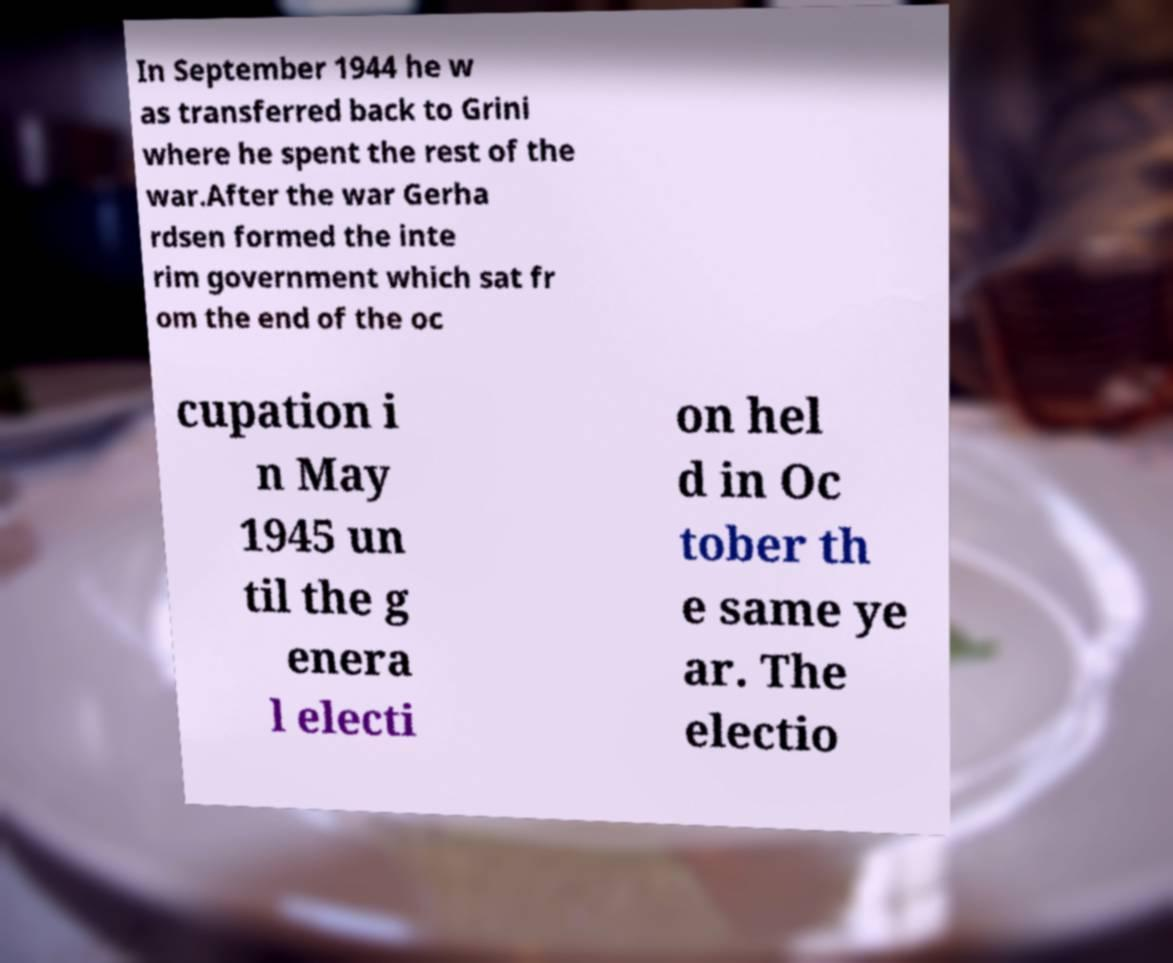Can you read and provide the text displayed in the image?This photo seems to have some interesting text. Can you extract and type it out for me? In September 1944 he w as transferred back to Grini where he spent the rest of the war.After the war Gerha rdsen formed the inte rim government which sat fr om the end of the oc cupation i n May 1945 un til the g enera l electi on hel d in Oc tober th e same ye ar. The electio 